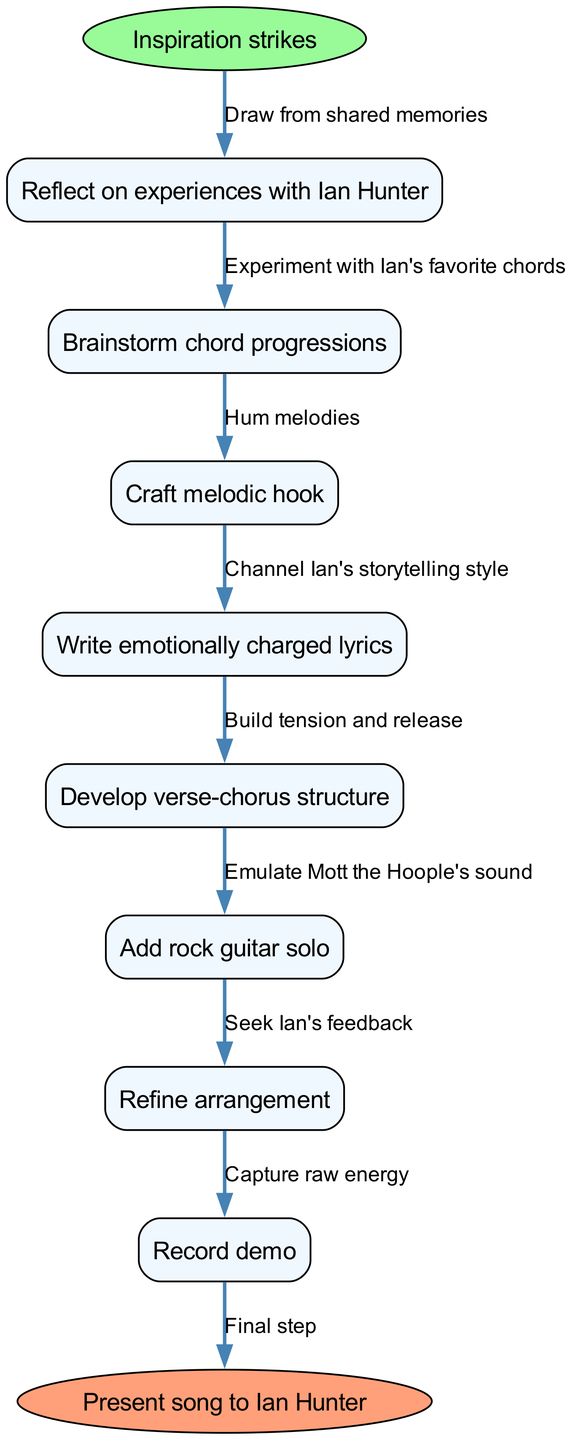What's the first step in the songwriting process? The diagram indicates that the process begins with "Inspiration strikes," which is the starting node.
Answer: Inspiration strikes How many nodes are present in the diagram? Count the nodes listed in the diagram, including the start and end node. There are a total of 9 nodes.
Answer: 9 Which node comes after "Reflect on experiences with Ian Hunter"? In the flow diagram, "Brainstorm chord progressions" is directly connected to "Reflect on experiences with Ian Hunter" as the next step.
Answer: Brainstorm chord progressions What is the last step before presenting the song to Ian Hunter? The final process before reaching the end node "Present song to Ian Hunter" is "Record demo," which connects directly to the end node.
Answer: Record demo Which edge connects "Craft melodic hook" to the next step? The edge connecting "Craft melodic hook" to "Write emotionally charged lyrics" indicates the transition between these two nodes. The description on the edge is "Channel Ian's storytelling style."
Answer: Channel Ian's storytelling style How does the node "Add rock guitar solo" relate to others in the structure? "Add rock guitar solo" follows "Develop verse-chorus structure," indicating it is an additional layer of the arrangement before refining.
Answer: Additional layer before refining What process occurs right after "Write emotionally charged lyrics"? The flow chart shows that the next process after "Write emotionally charged lyrics" is "Develop verse-chorus structure."
Answer: Develop verse-chorus structure How many edges are present connecting all nodes? The number of edges can be counted as the connections between nodes, including the start and end connections. There are 8 edges in total.
Answer: 8 What is the purpose of the last edge in the diagram? The last edge connects the final node "Record demo" to the end node "Present song to Ian Hunter," indicating the transition to the final step in the songwriting process.
Answer: Transition to final step 